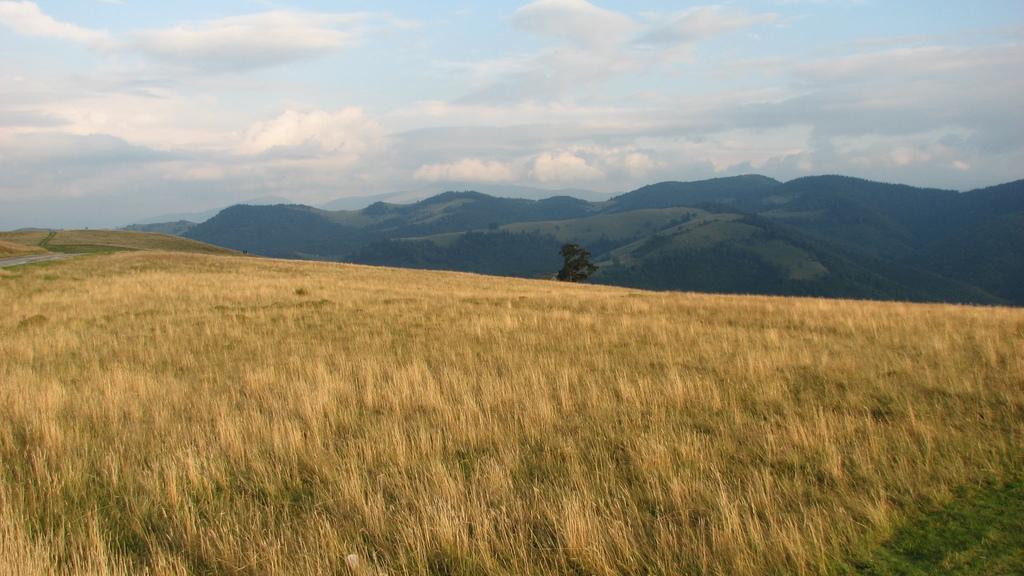Can you describe this image briefly? In this image we can see mountains, a tree and in the background, we can see the cloudy sky. 